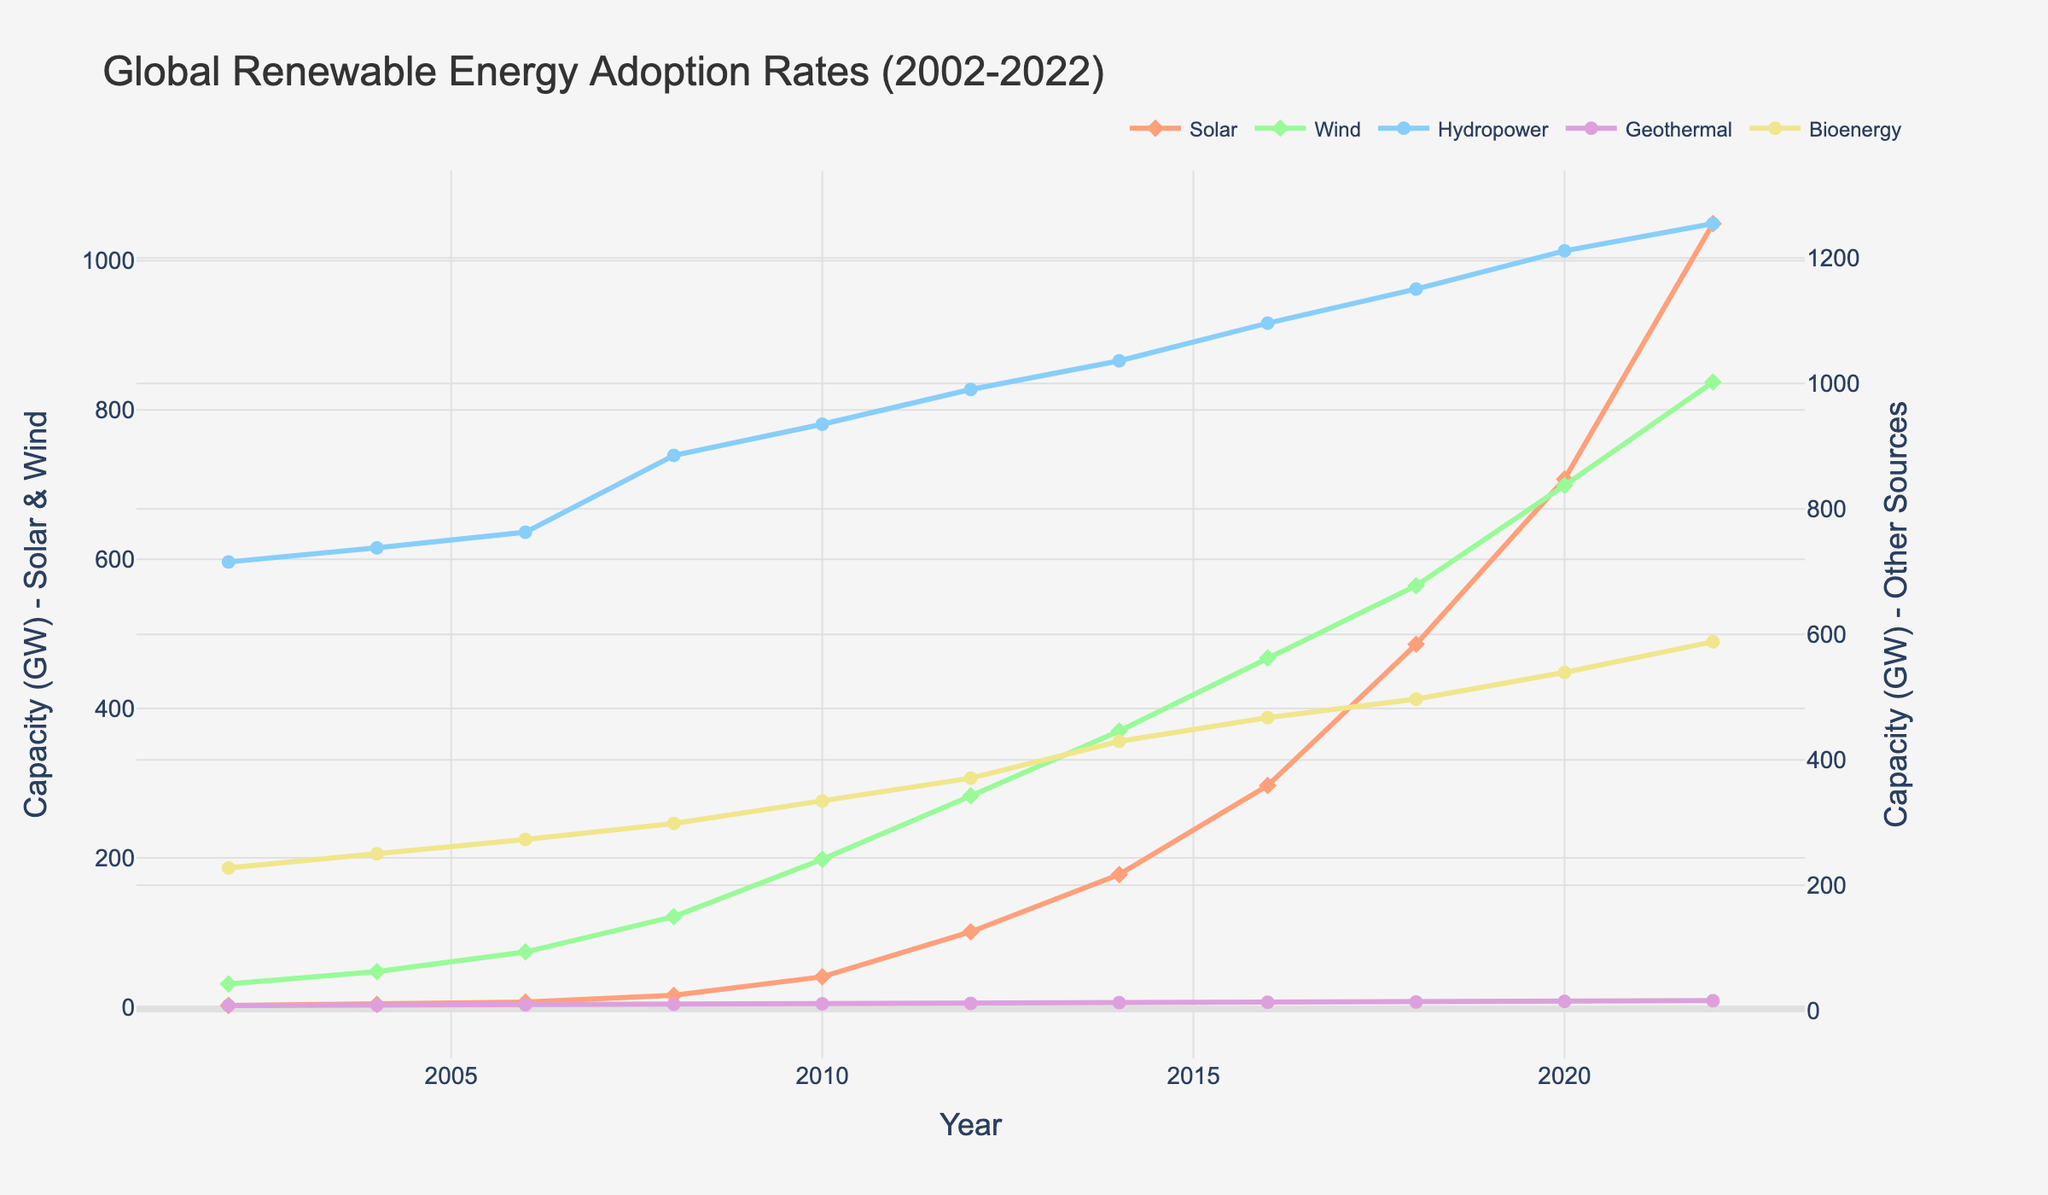What's the overall trend in solar energy adoption from 2002 to 2022? Observe the curve representing solar energy, it shows a significant rise over time, indicating an overall increasing trend.
Answer: Increasing Which energy type experienced the highest absolute increase in capacity between 2002 and 2022? Calculate the difference for all energy types: Solar (1049.6-2.2), Wind (837.3-31.1), Hydropower (1254.8-715.4), Geothermal (16.0-8.3), Bioenergy (588.1-227.6). Solar shows the highest absolute increase.
Answer: Solar What is the combined capacity of wind and bioenergy in 2018? Look at the values for wind (564.5 GW) and bioenergy (496.8 GW) in 2018, then sum them: 564.5 + 496.8 = 1061.3
Answer: 1061.3 GW How does the adoption rate of wind energy in 2010 compare to solar energy in the same year? Check the 2010 values for wind energy (198.0 GW) and solar energy (40.6 GW). Wind energy capacity is significantly higher.
Answer: Wind energy is higher Which energy types use circle markers in the plot? By observing the plot, note that hydropower, geothermal, and bioenergy all use circle markers.
Answer: Hydropower, Geothermal, Bioenergy What is the average annual increase in solar energy capacity from 2002 to 2022? Calculate the total increase (1049.6 - 2.2 = 1047.4 GW) and divide by the number of years (2022-2002 = 20). The average annual increase is 1047.4/20.
Answer: 52.37 GW/year Between which years did wind energy show the most significant increase in capacity? Observe the plot and identify the steepest slope, which appears between 2018 and 2020.
Answer: 2018 to 2020 Which energy type had the least growth in capacity from 2002 to 2022? Find the total increase for each type: Solar (1047.4), Wind (806.2), Hydropower (539.4), Geothermal (7.7), Bioenergy (360.5). Geothermal has the least growth.
Answer: Geothermal 